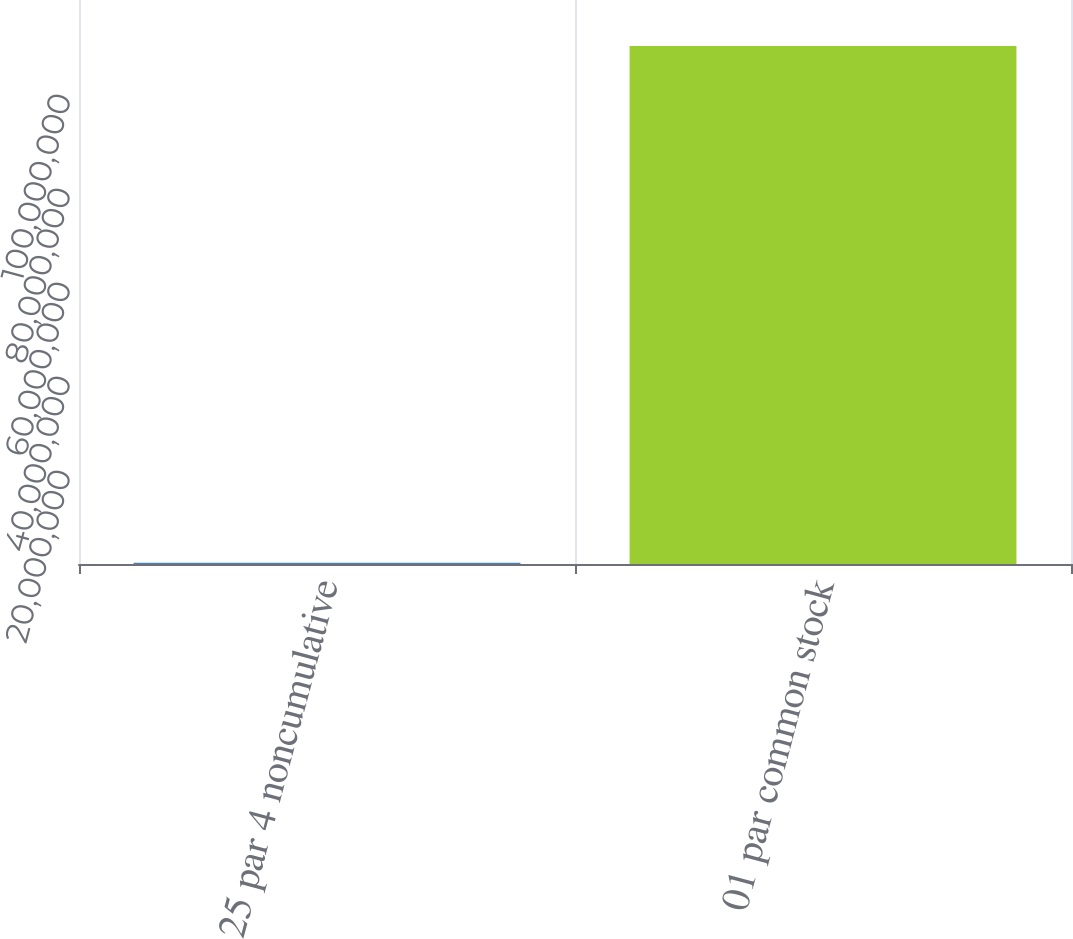Convert chart to OTSL. <chart><loc_0><loc_0><loc_500><loc_500><bar_chart><fcel>25 par 4 noncumulative<fcel>01 par common stock<nl><fcel>242170<fcel>1.10229e+08<nl></chart> 